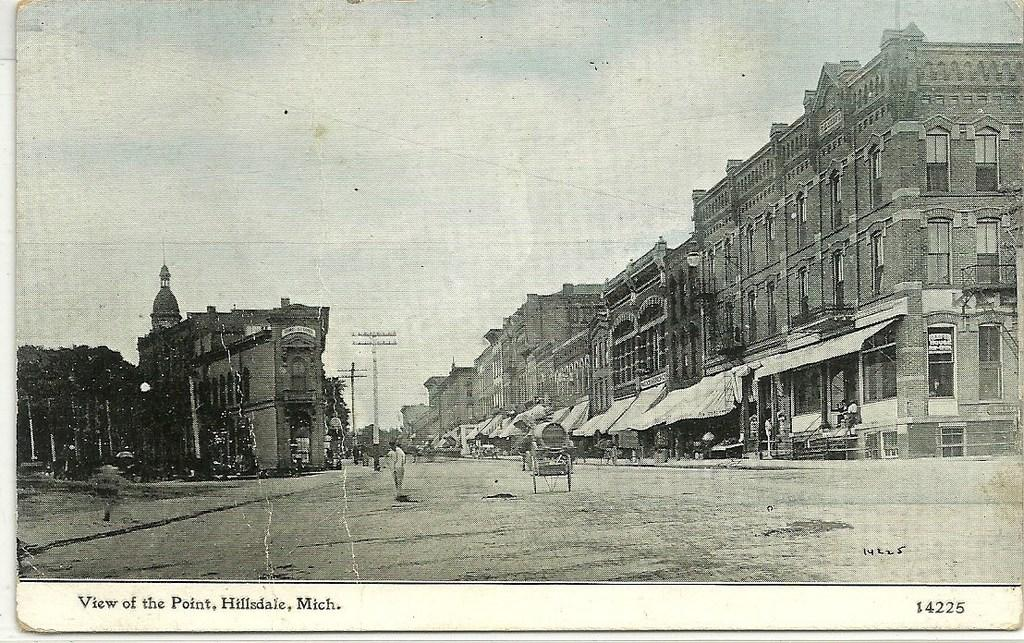What type of structures can be seen in the image? There are buildings in the image. Who or what else is present in the image? There are people in the image. What mode of transportation can be seen on the road in the image? There are vehicles on the road in the image. Can you tell me how many cows are pulling the vehicles in the image? There are no cows present in the image, and they are not pulling any vehicles. What invention is being used by the people in the image? The provided facts do not mention any specific invention being used by the people in the image. 